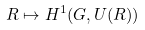Convert formula to latex. <formula><loc_0><loc_0><loc_500><loc_500>R \mapsto H ^ { 1 } ( G , U ( R ) )</formula> 